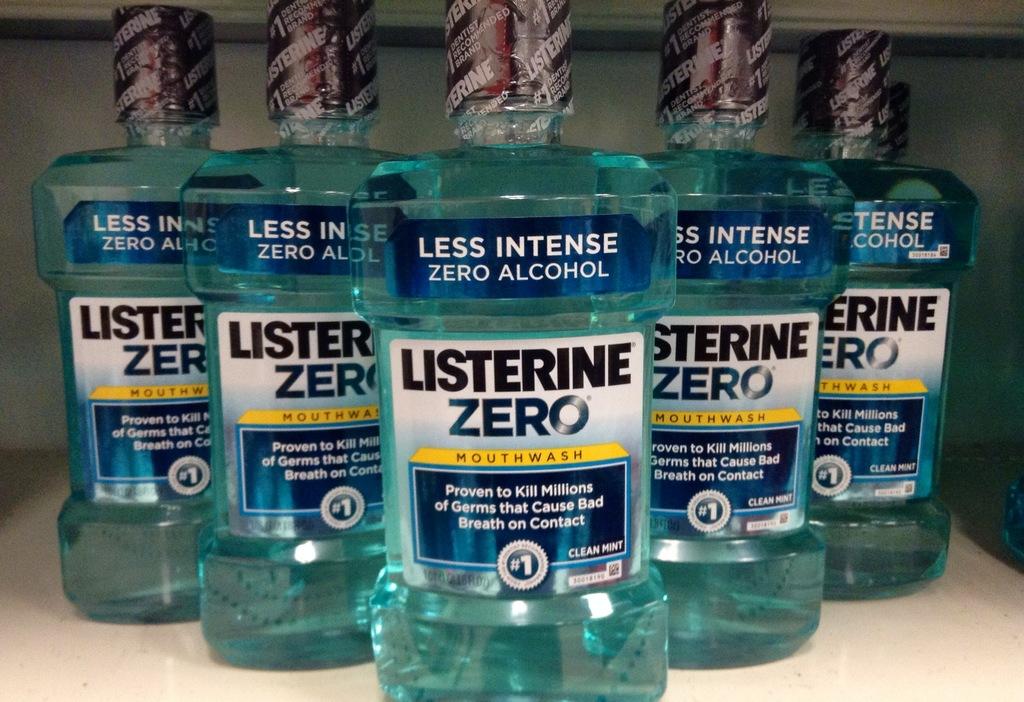What brand is the mouthwash?
Your answer should be very brief. Listerine. What flavor is the mouthwash?
Offer a very short reply. Clean mint. 